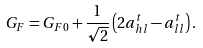<formula> <loc_0><loc_0><loc_500><loc_500>G _ { F } = G _ { F 0 } + \frac { 1 } { \sqrt { 2 } } \left ( 2 a _ { h l } ^ { t } - a _ { l l } ^ { t } \right ) .</formula> 